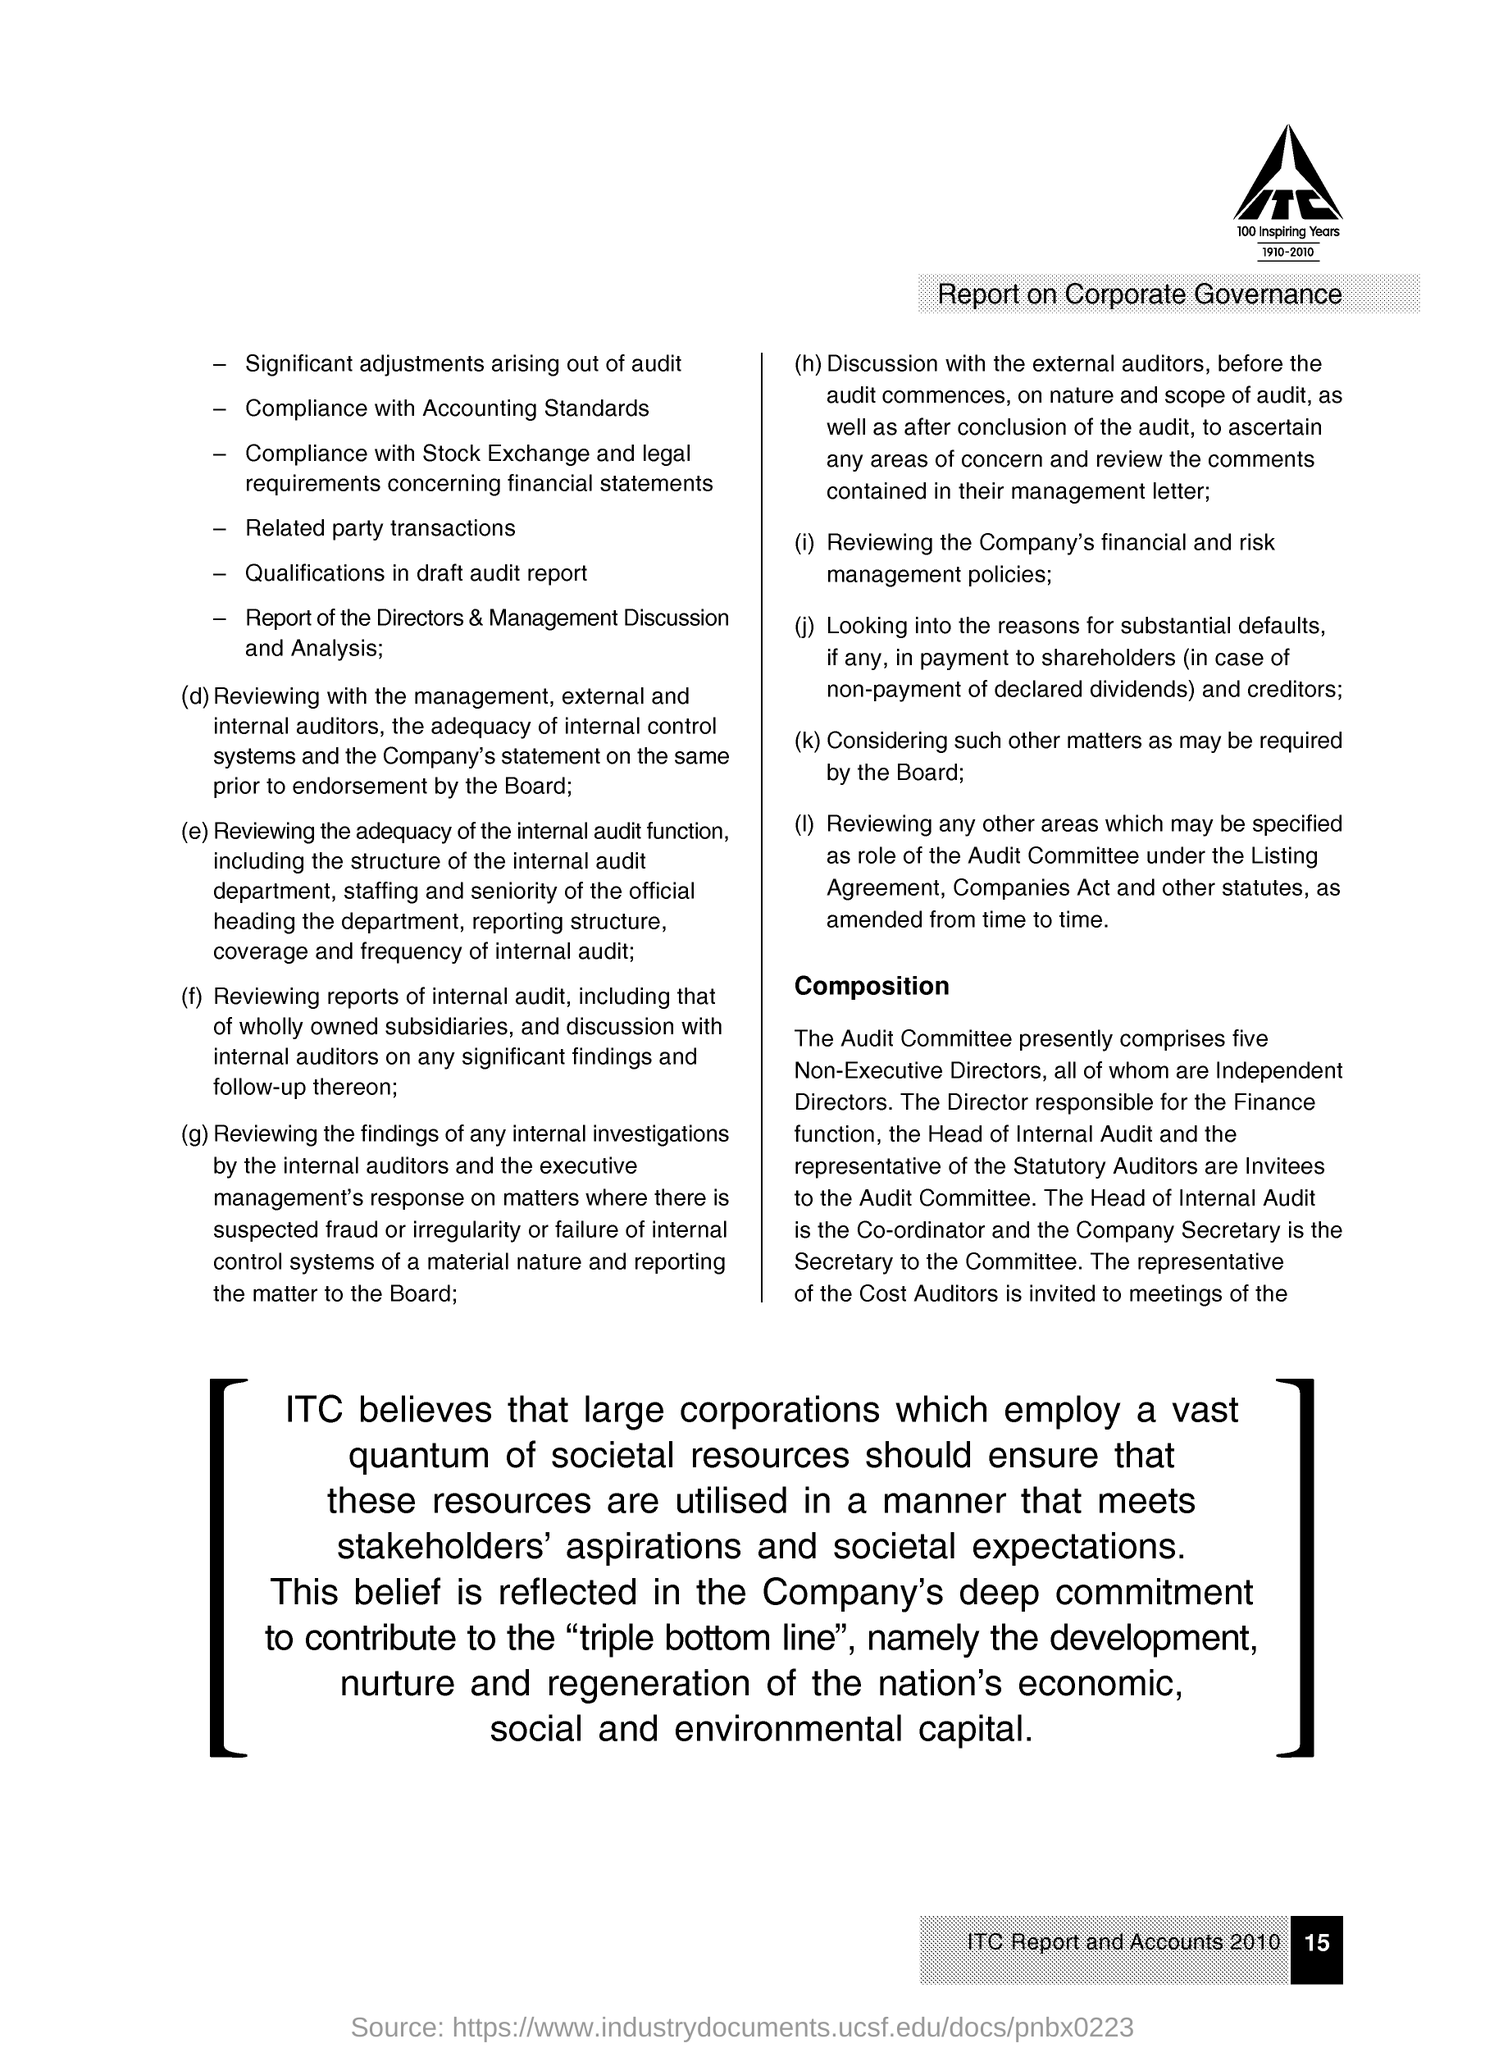Highlight a few significant elements in this photo. The head of Internal Audit is the Co-ordinator. The Secretary to the Committee is the Company Secretary. The Audit Committee currently has five Non-Executive Directors. 